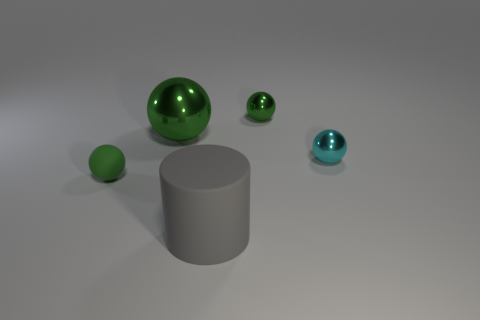How many green spheres must be subtracted to get 1 green spheres? 2 Subtract all cyan cylinders. How many green spheres are left? 3 Add 2 large brown matte balls. How many objects exist? 7 Subtract all balls. How many objects are left? 1 Add 4 cyan rubber blocks. How many cyan rubber blocks exist? 4 Subtract 0 red spheres. How many objects are left? 5 Subtract all gray objects. Subtract all gray rubber cylinders. How many objects are left? 3 Add 3 large things. How many large things are left? 5 